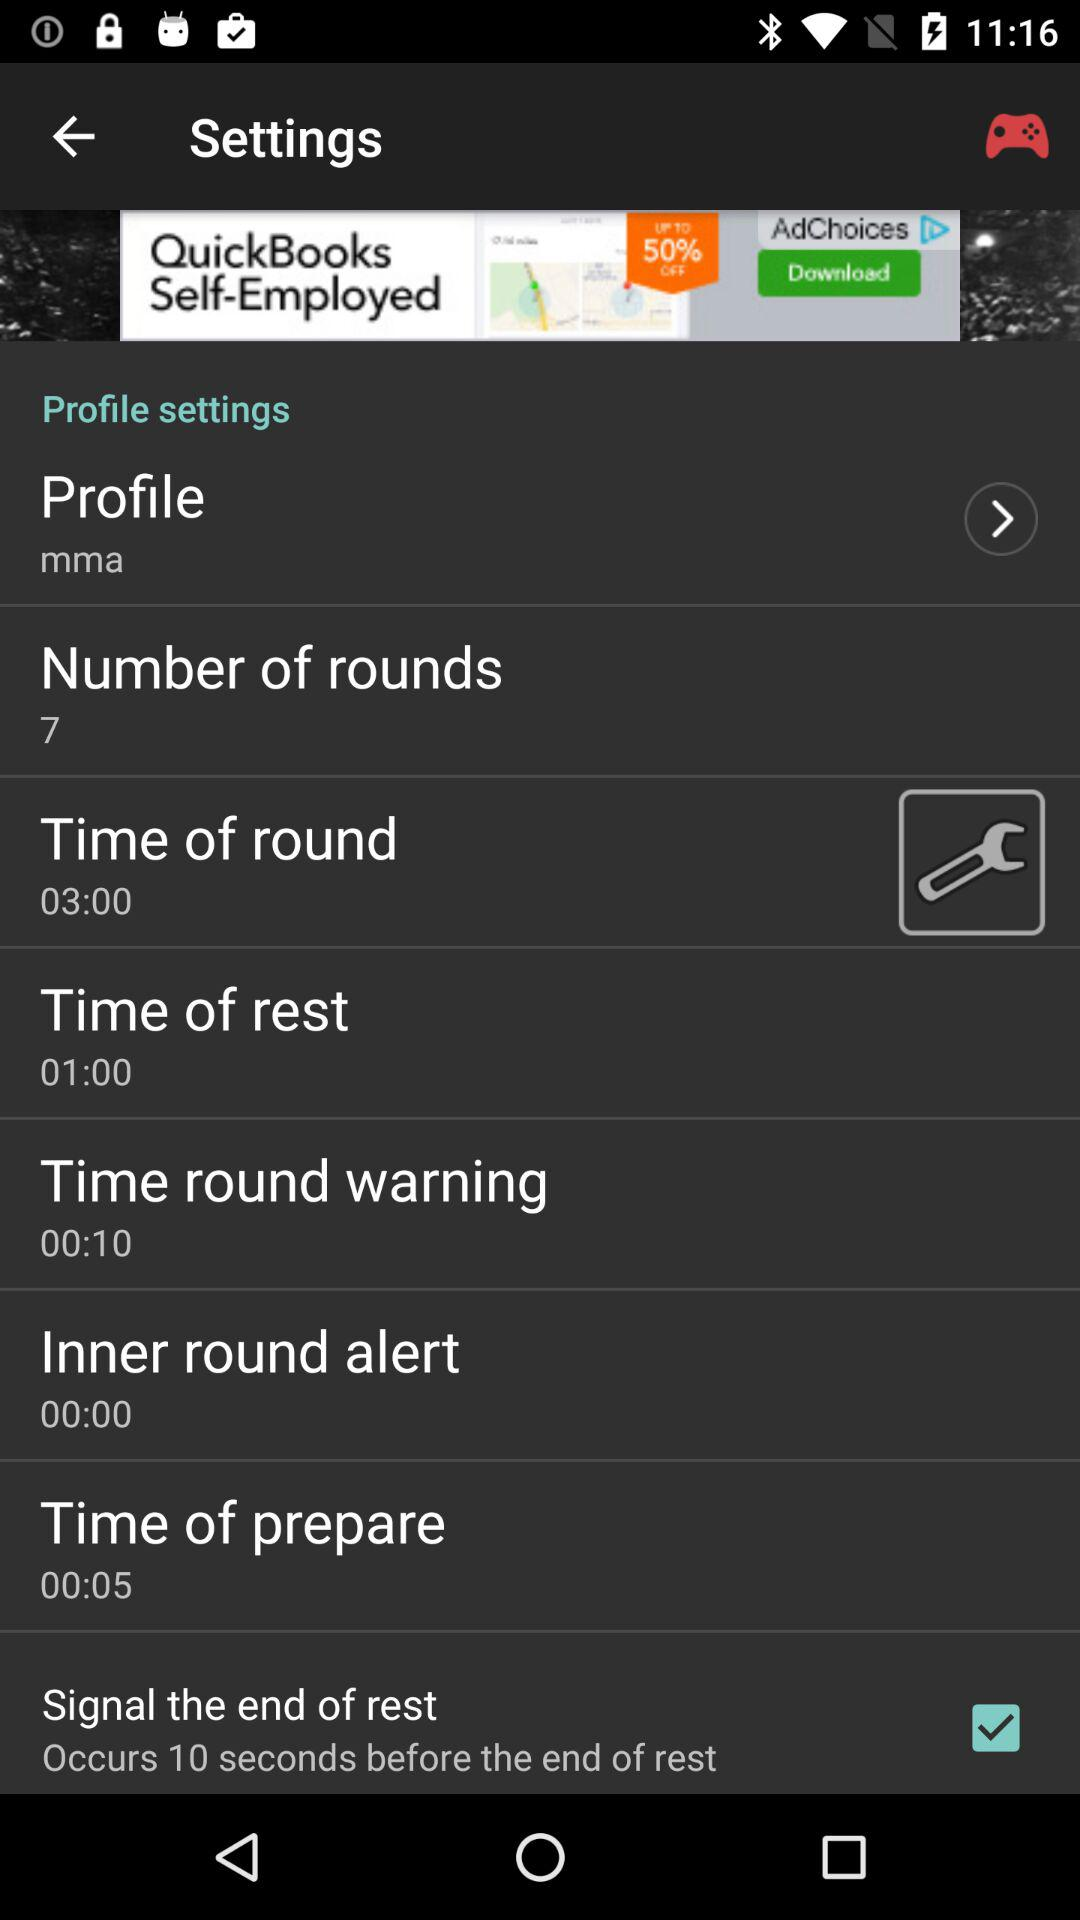What is the time in the inner round alert? The time is 00:00. 